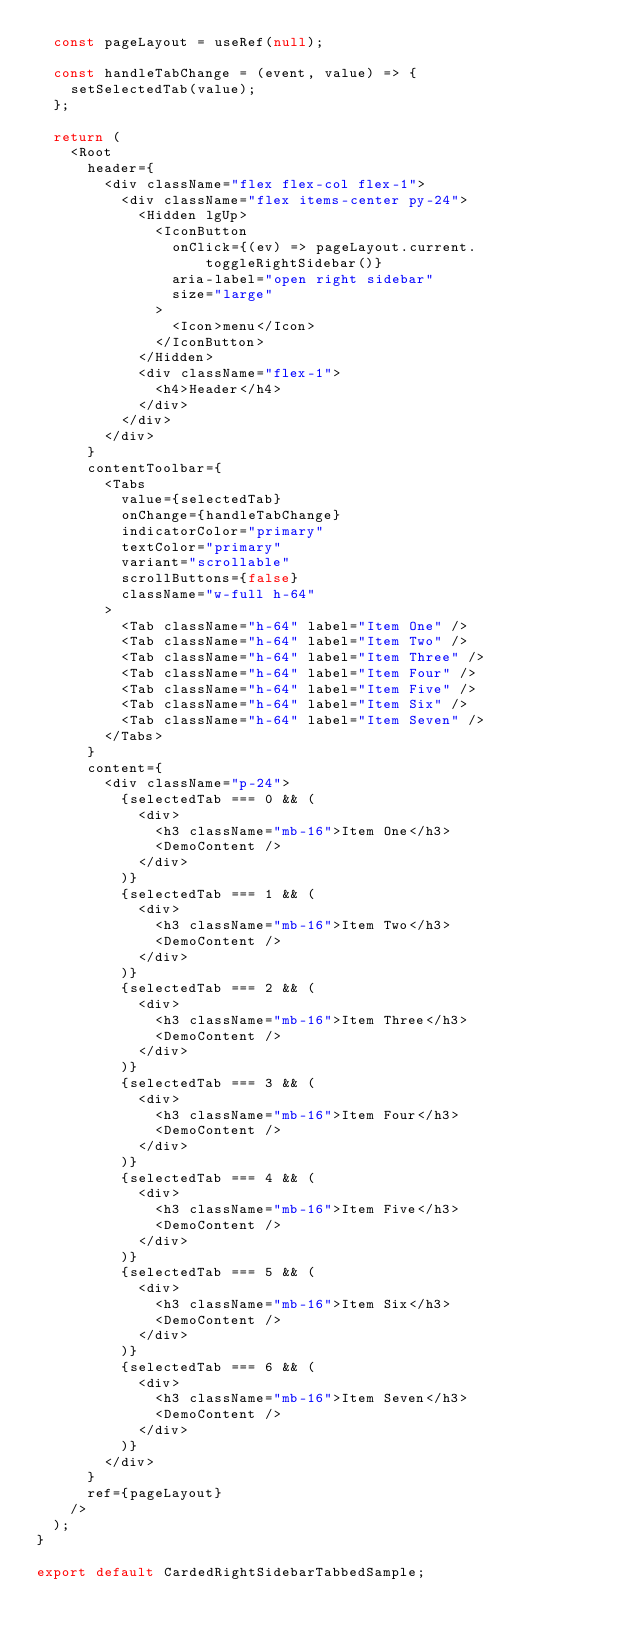<code> <loc_0><loc_0><loc_500><loc_500><_JavaScript_>  const pageLayout = useRef(null);

  const handleTabChange = (event, value) => {
    setSelectedTab(value);
  };

  return (
    <Root
      header={
        <div className="flex flex-col flex-1">
          <div className="flex items-center py-24">
            <Hidden lgUp>
              <IconButton
                onClick={(ev) => pageLayout.current.toggleRightSidebar()}
                aria-label="open right sidebar"
                size="large"
              >
                <Icon>menu</Icon>
              </IconButton>
            </Hidden>
            <div className="flex-1">
              <h4>Header</h4>
            </div>
          </div>
        </div>
      }
      contentToolbar={
        <Tabs
          value={selectedTab}
          onChange={handleTabChange}
          indicatorColor="primary"
          textColor="primary"
          variant="scrollable"
          scrollButtons={false}
          className="w-full h-64"
        >
          <Tab className="h-64" label="Item One" />
          <Tab className="h-64" label="Item Two" />
          <Tab className="h-64" label="Item Three" />
          <Tab className="h-64" label="Item Four" />
          <Tab className="h-64" label="Item Five" />
          <Tab className="h-64" label="Item Six" />
          <Tab className="h-64" label="Item Seven" />
        </Tabs>
      }
      content={
        <div className="p-24">
          {selectedTab === 0 && (
            <div>
              <h3 className="mb-16">Item One</h3>
              <DemoContent />
            </div>
          )}
          {selectedTab === 1 && (
            <div>
              <h3 className="mb-16">Item Two</h3>
              <DemoContent />
            </div>
          )}
          {selectedTab === 2 && (
            <div>
              <h3 className="mb-16">Item Three</h3>
              <DemoContent />
            </div>
          )}
          {selectedTab === 3 && (
            <div>
              <h3 className="mb-16">Item Four</h3>
              <DemoContent />
            </div>
          )}
          {selectedTab === 4 && (
            <div>
              <h3 className="mb-16">Item Five</h3>
              <DemoContent />
            </div>
          )}
          {selectedTab === 5 && (
            <div>
              <h3 className="mb-16">Item Six</h3>
              <DemoContent />
            </div>
          )}
          {selectedTab === 6 && (
            <div>
              <h3 className="mb-16">Item Seven</h3>
              <DemoContent />
            </div>
          )}
        </div>
      }
      ref={pageLayout}
    />
  );
}

export default CardedRightSidebarTabbedSample;
</code> 